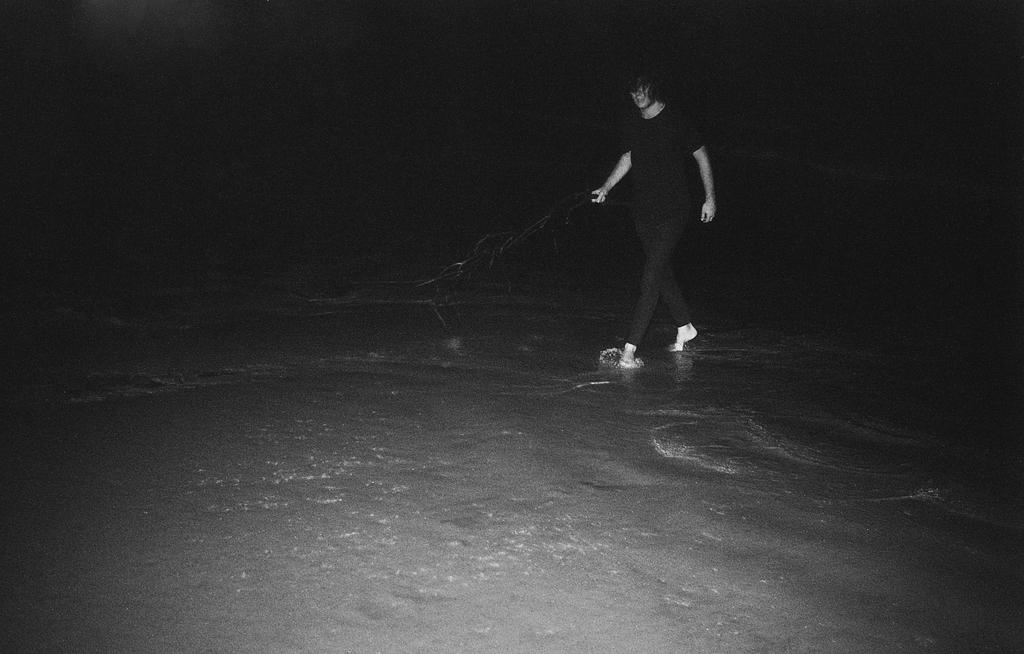Who is present in the image? There is a woman in the image. Where is the woman located? The woman is standing on the sea shore. What is the lighting condition in the image? The scene is set in the dark. What type of quill can be seen in the woman's hand in the image? There is no quill present in the image; the woman is standing on the sea shore in the dark. 